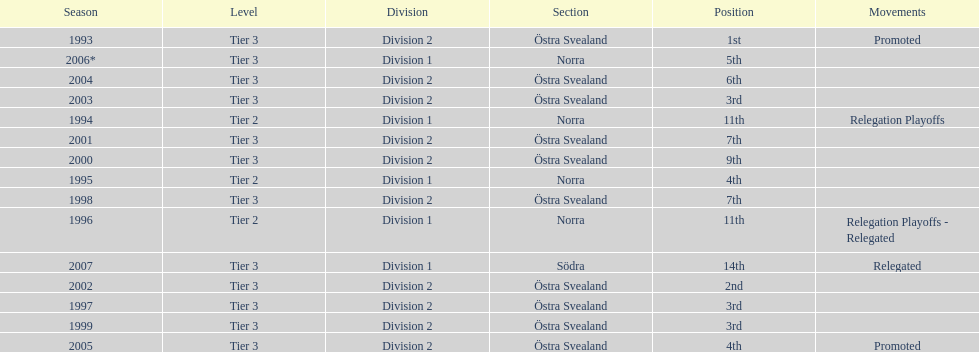What is mentioned under the movements column of the previous season? Relegated. 